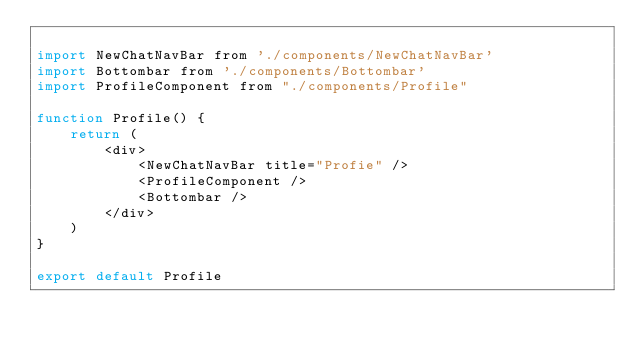<code> <loc_0><loc_0><loc_500><loc_500><_JavaScript_>
import NewChatNavBar from './components/NewChatNavBar'
import Bottombar from './components/Bottombar'
import ProfileComponent from "./components/Profile"

function Profile() {
    return (
        <div>
            <NewChatNavBar title="Profie" />
            <ProfileComponent />
            <Bottombar />
        </div>
    )
}

export default Profile
</code> 